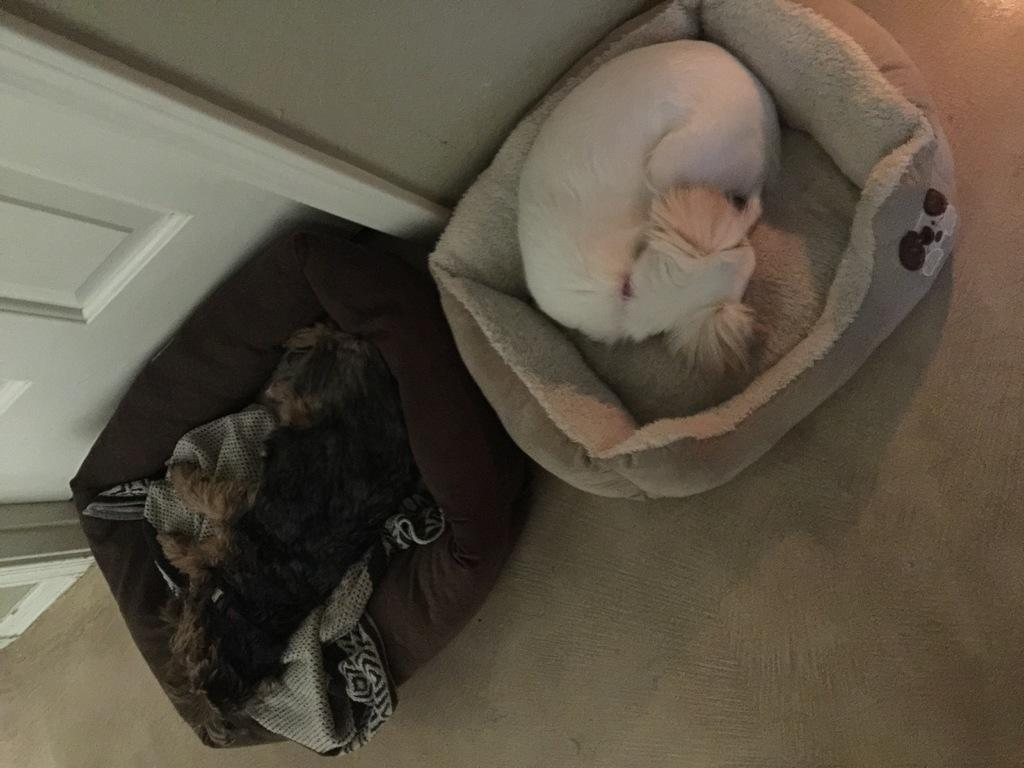What type of animals can be seen in the image? There are dogs in the image. What are the dogs doing in the image? The dogs are lying on dog beds. Where are the dog beds located in the image? The dog beds are on the floor. What can be seen in the background of the image? There is a wall and a door in the background of the image. How many people are in the crowd in the image? There is no crowd present in the image; it features dogs lying on dog beds. What type of mouth can be seen on the dogs in the image? The image does not show the dogs' mouths; it only shows their bodies lying on dog beds. 